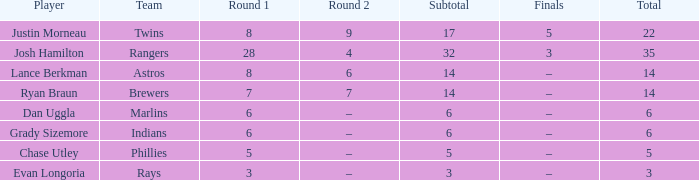Who is the player with a subtotal greater than 3 and 8 in the first round? Josh Hamilton. 